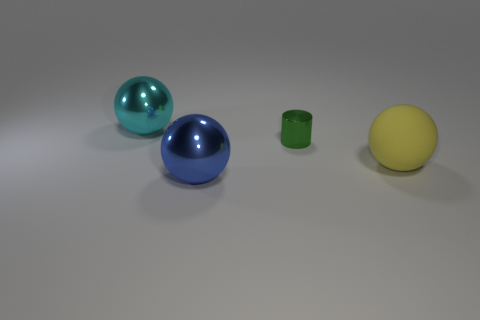Is there any other thing that is made of the same material as the yellow ball?
Ensure brevity in your answer.  No. How many tiny green balls are there?
Your answer should be compact. 0. What is the shape of the tiny metallic object that is behind the large yellow sphere behind the metallic sphere in front of the big cyan metal thing?
Provide a succinct answer. Cylinder. Is the number of cyan objects in front of the green thing less than the number of spheres that are behind the large yellow ball?
Provide a succinct answer. Yes. Is the shape of the large thing in front of the large rubber object the same as the large thing that is right of the small metallic object?
Your response must be concise. Yes. What shape is the big metal object to the left of the large ball in front of the yellow matte ball?
Make the answer very short. Sphere. Are there any large red objects that have the same material as the blue ball?
Give a very brief answer. No. There is a object in front of the big yellow matte thing; what is it made of?
Make the answer very short. Metal. What is the big yellow ball made of?
Give a very brief answer. Rubber. Does the big object behind the yellow sphere have the same material as the small cylinder?
Ensure brevity in your answer.  Yes. 